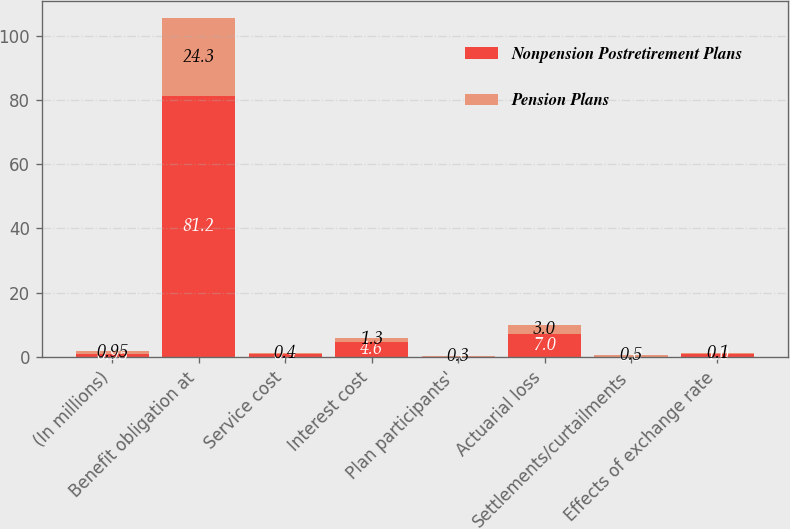Convert chart. <chart><loc_0><loc_0><loc_500><loc_500><stacked_bar_chart><ecel><fcel>(In millions)<fcel>Benefit obligation at<fcel>Service cost<fcel>Interest cost<fcel>Plan participants'<fcel>Actuarial loss<fcel>Settlements/curtailments<fcel>Effects of exchange rate<nl><fcel>Nonpension Postretirement Plans<fcel>0.95<fcel>81.2<fcel>0.9<fcel>4.6<fcel>0<fcel>7<fcel>0<fcel>1<nl><fcel>Pension Plans<fcel>0.95<fcel>24.3<fcel>0.4<fcel>1.3<fcel>0.3<fcel>3<fcel>0.5<fcel>0.1<nl></chart> 